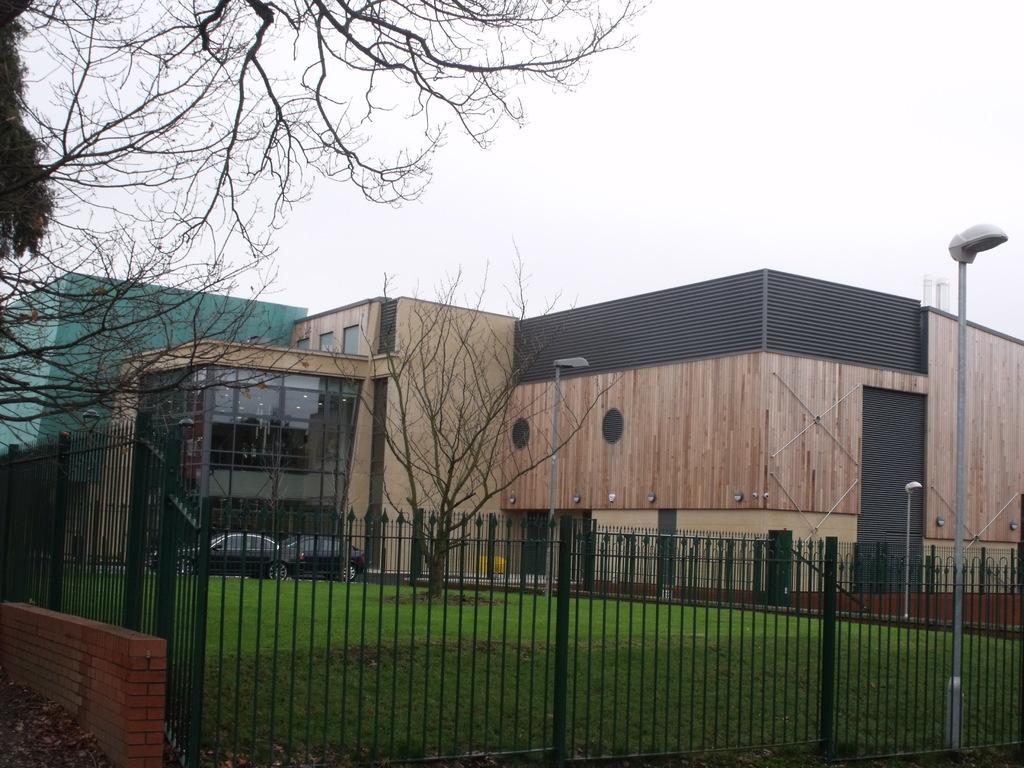Can you describe this image briefly? In this image in the front there is fence which is black in colour and there is a wall. In the center there is grass on the ground and there is a dry tree and in the background there is a building and in front of the building there are cars. Behind the building there is a cloth which is green in colour and the sky is cloudy. In the front on the top left there is a dry tree and on the right side there are poles. 